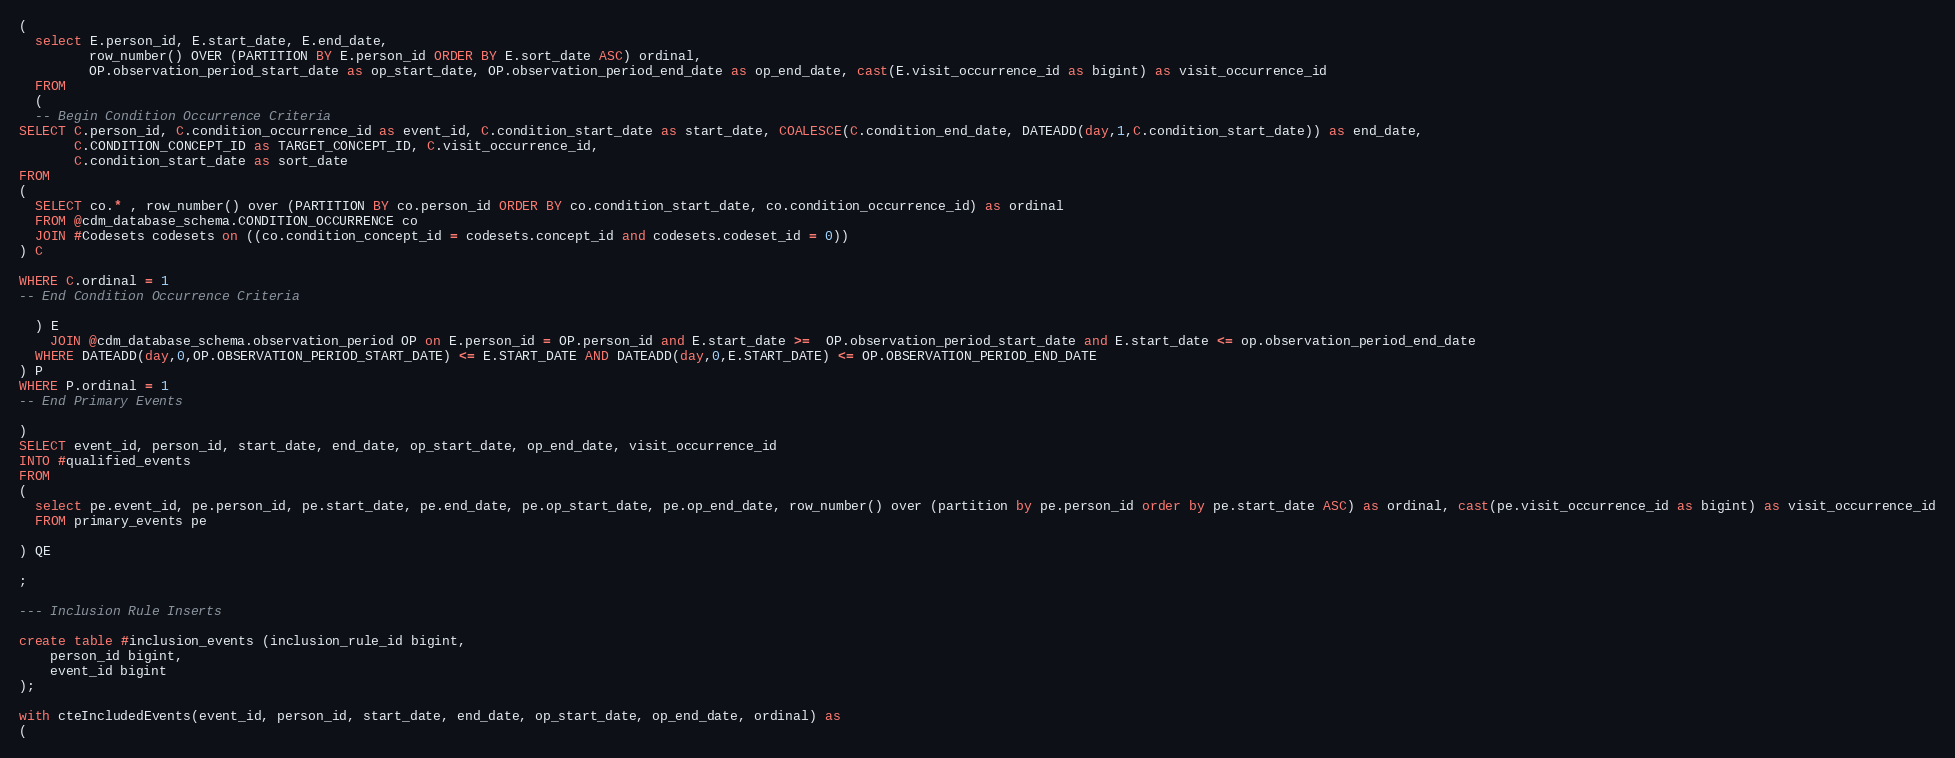Convert code to text. <code><loc_0><loc_0><loc_500><loc_500><_SQL_>(
  select E.person_id, E.start_date, E.end_date,
         row_number() OVER (PARTITION BY E.person_id ORDER BY E.sort_date ASC) ordinal,
         OP.observation_period_start_date as op_start_date, OP.observation_period_end_date as op_end_date, cast(E.visit_occurrence_id as bigint) as visit_occurrence_id
  FROM 
  (
  -- Begin Condition Occurrence Criteria
SELECT C.person_id, C.condition_occurrence_id as event_id, C.condition_start_date as start_date, COALESCE(C.condition_end_date, DATEADD(day,1,C.condition_start_date)) as end_date,
       C.CONDITION_CONCEPT_ID as TARGET_CONCEPT_ID, C.visit_occurrence_id,
       C.condition_start_date as sort_date
FROM 
(
  SELECT co.* , row_number() over (PARTITION BY co.person_id ORDER BY co.condition_start_date, co.condition_occurrence_id) as ordinal
  FROM @cdm_database_schema.CONDITION_OCCURRENCE co
  JOIN #Codesets codesets on ((co.condition_concept_id = codesets.concept_id and codesets.codeset_id = 0))
) C

WHERE C.ordinal = 1
-- End Condition Occurrence Criteria

  ) E
	JOIN @cdm_database_schema.observation_period OP on E.person_id = OP.person_id and E.start_date >=  OP.observation_period_start_date and E.start_date <= op.observation_period_end_date
  WHERE DATEADD(day,0,OP.OBSERVATION_PERIOD_START_DATE) <= E.START_DATE AND DATEADD(day,0,E.START_DATE) <= OP.OBSERVATION_PERIOD_END_DATE
) P
WHERE P.ordinal = 1
-- End Primary Events

)
SELECT event_id, person_id, start_date, end_date, op_start_date, op_end_date, visit_occurrence_id
INTO #qualified_events
FROM 
(
  select pe.event_id, pe.person_id, pe.start_date, pe.end_date, pe.op_start_date, pe.op_end_date, row_number() over (partition by pe.person_id order by pe.start_date ASC) as ordinal, cast(pe.visit_occurrence_id as bigint) as visit_occurrence_id
  FROM primary_events pe
  
) QE

;

--- Inclusion Rule Inserts

create table #inclusion_events (inclusion_rule_id bigint,
	person_id bigint,
	event_id bigint
);

with cteIncludedEvents(event_id, person_id, start_date, end_date, op_start_date, op_end_date, ordinal) as
(</code> 